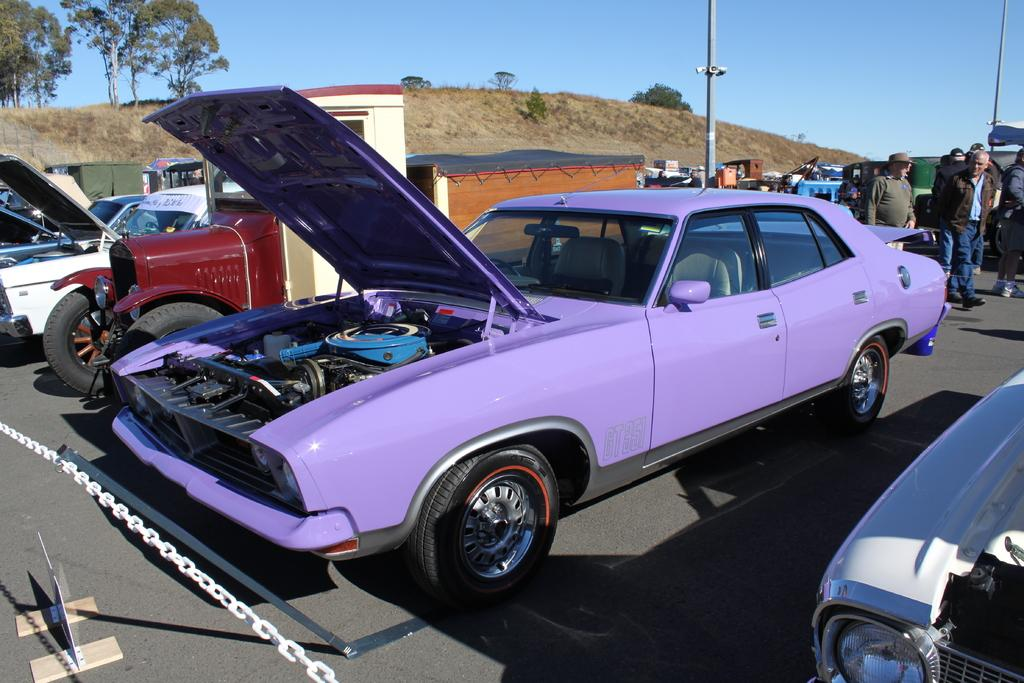What can be seen on the road in the image? There are cars parked on the road in the image. What are the people near the car doing? There are people standing near the car in the image. What object is present in the image that is made of metal? There is an iron chain in the image. What type of vegetation is visible behind the iron chain? There are trees behind the iron chain in the image. What is the condition of the sky in the image? The sky is clear in the image. Can you see a bottle of water in the hands of the dog in the image? There is no dog present in the image, and therefore no bottle of water can be seen in its hands. 